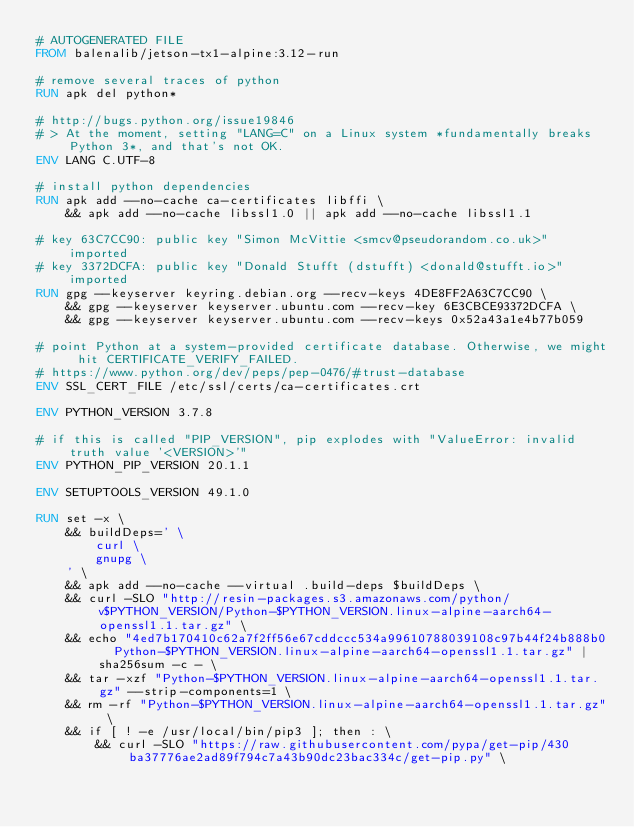Convert code to text. <code><loc_0><loc_0><loc_500><loc_500><_Dockerfile_># AUTOGENERATED FILE
FROM balenalib/jetson-tx1-alpine:3.12-run

# remove several traces of python
RUN apk del python*

# http://bugs.python.org/issue19846
# > At the moment, setting "LANG=C" on a Linux system *fundamentally breaks Python 3*, and that's not OK.
ENV LANG C.UTF-8

# install python dependencies
RUN apk add --no-cache ca-certificates libffi \
	&& apk add --no-cache libssl1.0 || apk add --no-cache libssl1.1

# key 63C7CC90: public key "Simon McVittie <smcv@pseudorandom.co.uk>" imported
# key 3372DCFA: public key "Donald Stufft (dstufft) <donald@stufft.io>" imported
RUN gpg --keyserver keyring.debian.org --recv-keys 4DE8FF2A63C7CC90 \
	&& gpg --keyserver keyserver.ubuntu.com --recv-key 6E3CBCE93372DCFA \
	&& gpg --keyserver keyserver.ubuntu.com --recv-keys 0x52a43a1e4b77b059

# point Python at a system-provided certificate database. Otherwise, we might hit CERTIFICATE_VERIFY_FAILED.
# https://www.python.org/dev/peps/pep-0476/#trust-database
ENV SSL_CERT_FILE /etc/ssl/certs/ca-certificates.crt

ENV PYTHON_VERSION 3.7.8

# if this is called "PIP_VERSION", pip explodes with "ValueError: invalid truth value '<VERSION>'"
ENV PYTHON_PIP_VERSION 20.1.1

ENV SETUPTOOLS_VERSION 49.1.0

RUN set -x \
	&& buildDeps=' \
		curl \
		gnupg \
	' \
	&& apk add --no-cache --virtual .build-deps $buildDeps \
	&& curl -SLO "http://resin-packages.s3.amazonaws.com/python/v$PYTHON_VERSION/Python-$PYTHON_VERSION.linux-alpine-aarch64-openssl1.1.tar.gz" \
	&& echo "4ed7b170410c62a7f2ff56e67cddccc534a99610788039108c97b44f24b888b0  Python-$PYTHON_VERSION.linux-alpine-aarch64-openssl1.1.tar.gz" | sha256sum -c - \
	&& tar -xzf "Python-$PYTHON_VERSION.linux-alpine-aarch64-openssl1.1.tar.gz" --strip-components=1 \
	&& rm -rf "Python-$PYTHON_VERSION.linux-alpine-aarch64-openssl1.1.tar.gz" \
	&& if [ ! -e /usr/local/bin/pip3 ]; then : \
		&& curl -SLO "https://raw.githubusercontent.com/pypa/get-pip/430ba37776ae2ad89f794c7a43b90dc23bac334c/get-pip.py" \</code> 